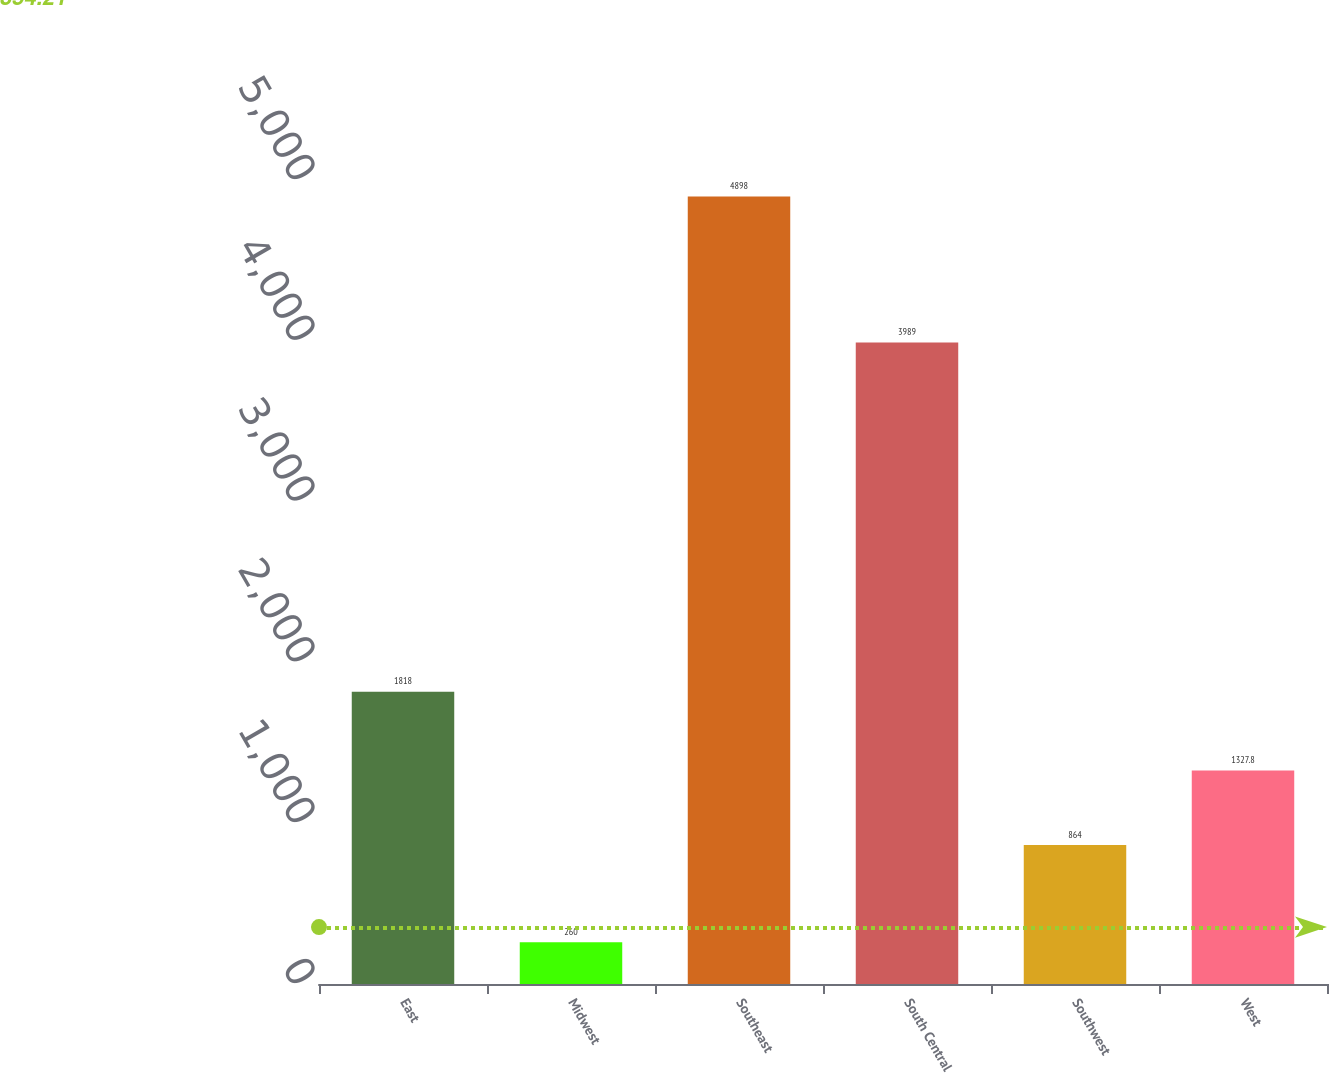Convert chart. <chart><loc_0><loc_0><loc_500><loc_500><bar_chart><fcel>East<fcel>Midwest<fcel>Southeast<fcel>South Central<fcel>Southwest<fcel>West<nl><fcel>1818<fcel>260<fcel>4898<fcel>3989<fcel>864<fcel>1327.8<nl></chart> 